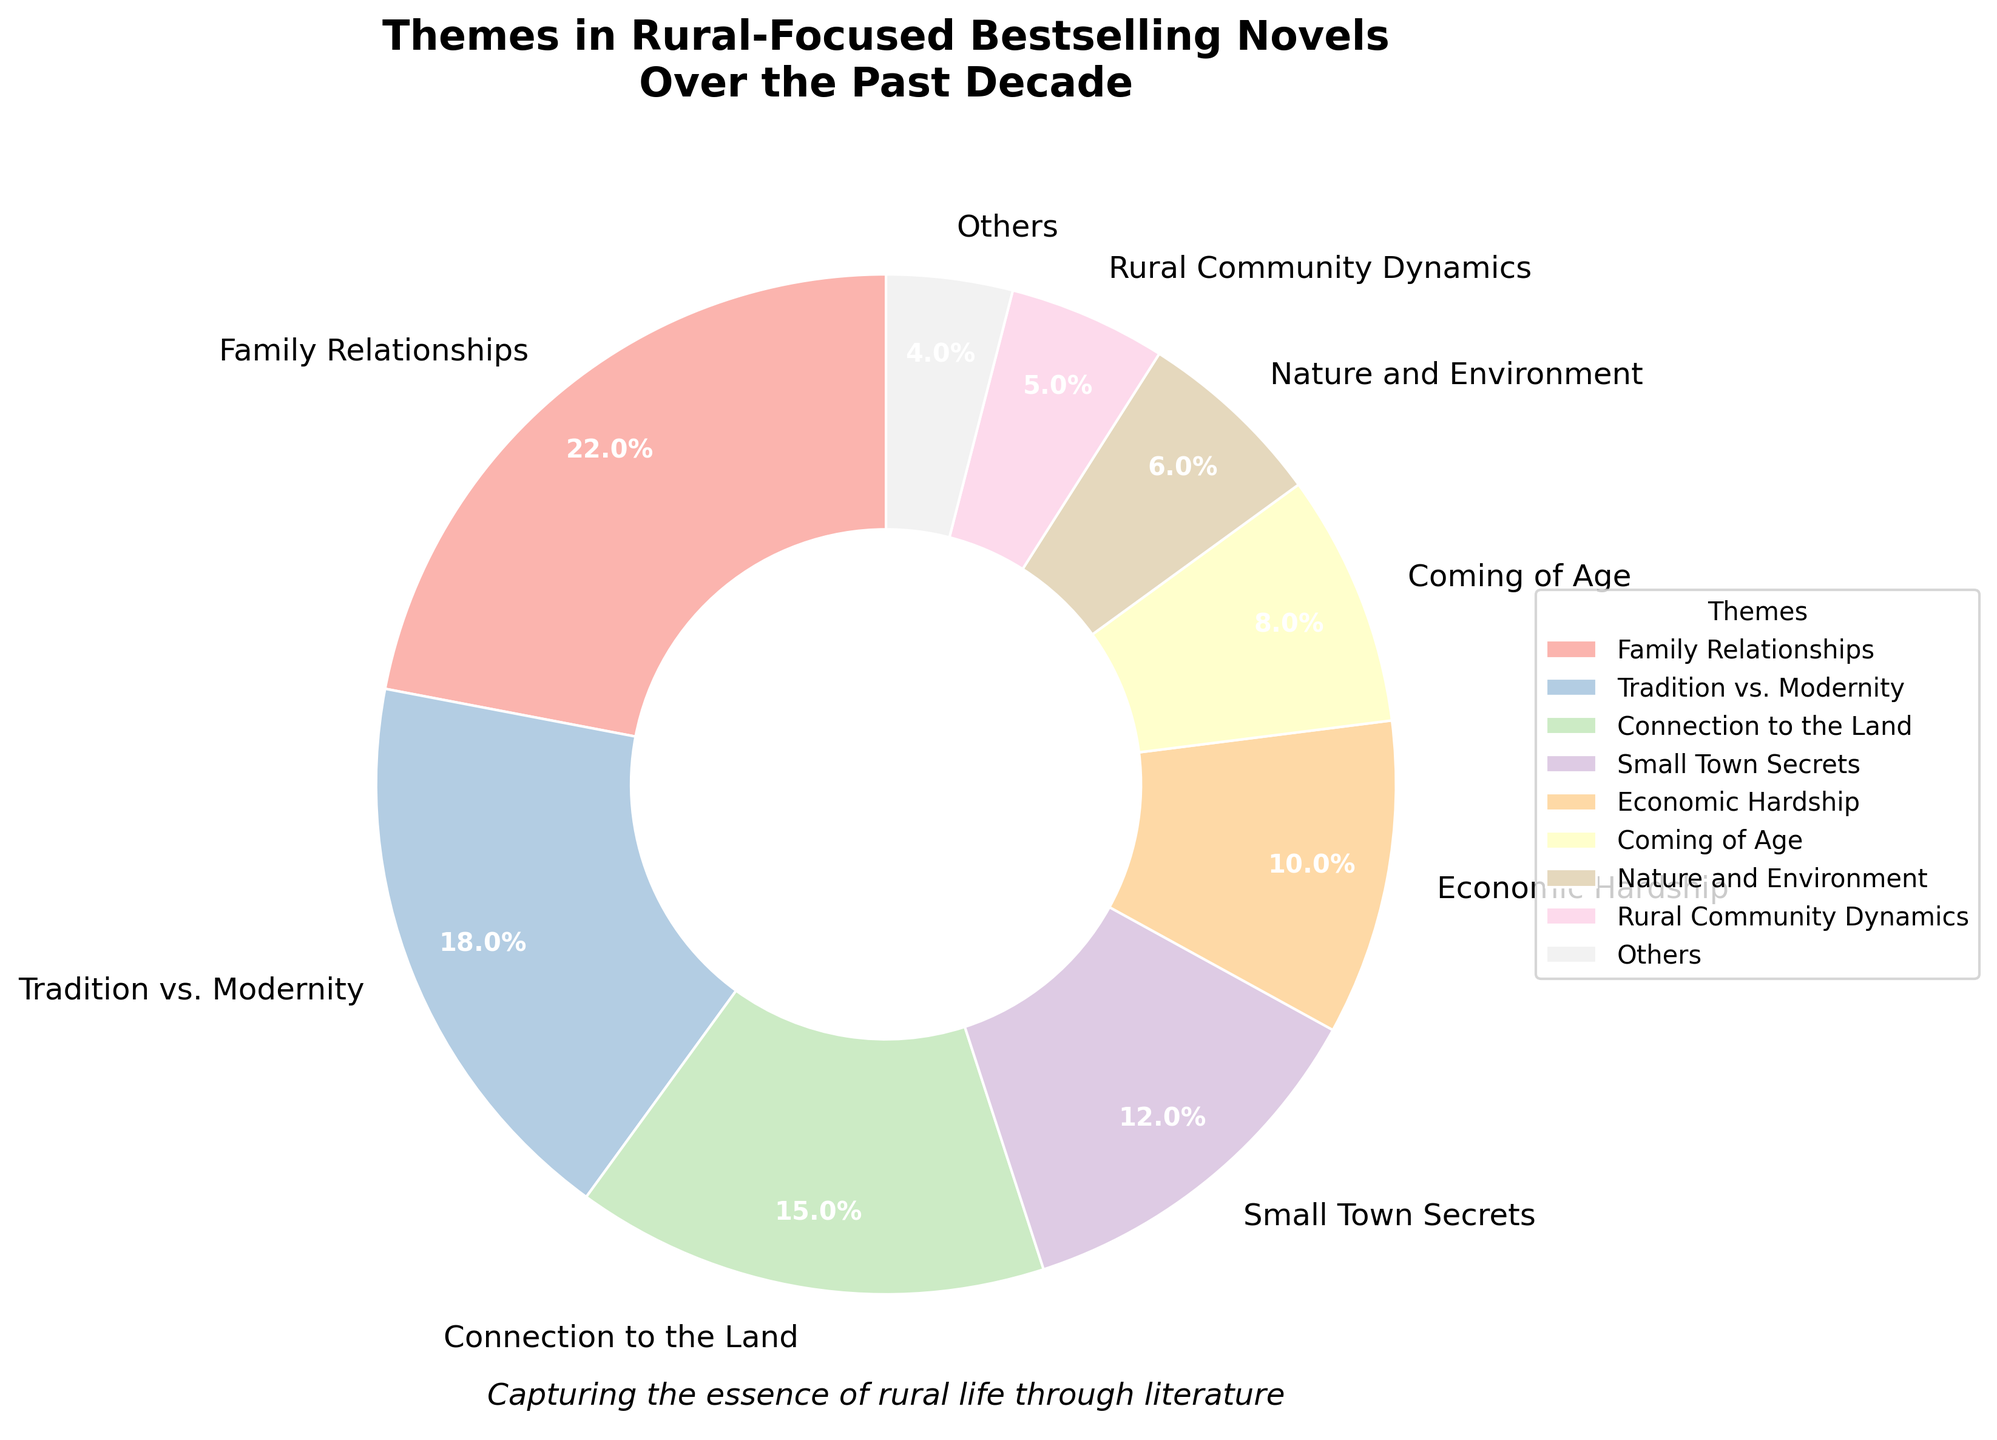What is the most common theme in rural-focused bestselling novels over the past decade? The figure shows that the theme with the largest sector is "Family Relationships" with 22%, which is more than any other theme.
Answer: Family Relationships Which themes account for a combined total of more than 30%? By looking at the pie chart, "Family Relationships" (22%), "Tradition vs. Modernity" (18%), and "Connection to the Land" (15%) individually add up to more than 30%. Specifically, adding Family Relationships and Tradition vs. Modernity equals 40%, which is already more than 30%.
Answer: "Family Relationships" and "Tradition vs. Modernity" What percentage of themes have less than 5%? The chart has a section labeled "Others," which includes themes with less than 5%. The percentage for "Others" is broken down into themes adding up to 13% (sum of individual percentages less than 5%).
Answer: 13% How much larger is the percentage of "Economic Hardship" compared to "Coming of Age"? "Economic Hardship" has 10%, while "Coming of Age" has 8%. The difference is (10% - 8%) = 2%.
Answer: 2% Which theme related to emotions or feelings has the smallest percentage? By observing the pie chart, "Isolation and Loneliness" is an emotion-related theme with a percentage of 3%, which is the smallest among all emotion-related themes shown.
Answer: Isolation and Loneliness What is the combined percentage for "Nature and Environment" and "Rural Community Dynamics"? "Nature and Environment" has 6%, and "Rural Community Dynamics" has 5%. Their combined percentage is (6% + 5%) = 11%.
Answer: 11% Which themes, if combined, would match the percentage of "Family Relationships"? "Small Town Secrets" (12%) and "Economic Hardship" (10%) together add up to (12% + 10%) = 22%, matching "Family Relationships".
Answer: "Small Town Secrets" and "Economic Hardship" How does "Tradition vs. Modernity" compare to "Connection to the Land" in terms of percentage? "Tradition vs. Modernity" has 18%, which is 3% higher than "Connection to the Land" with 15%.
Answer: "Tradition vs. Modernity" is 3% higher What is the second most common theme? The theme with the second-largest slice after "Family Relationships" is "Tradition vs. Modernity" with 18%.
Answer: Tradition vs. Modernity How much smaller is "Rural Healthcare Issues" compared to the largest theme? "Rural Healthcare Issues" is 1%, while "Family Relationships" is 22%. The difference is (22% - 1%) = 21%.
Answer: 21% 